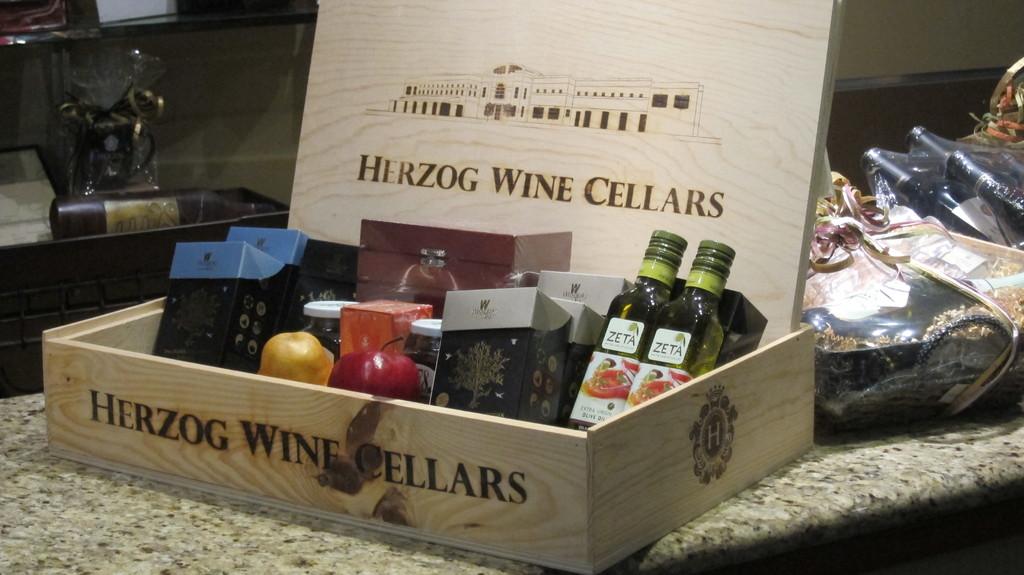What does it say on the green bottle labels?
Keep it short and to the point. Zeta. 